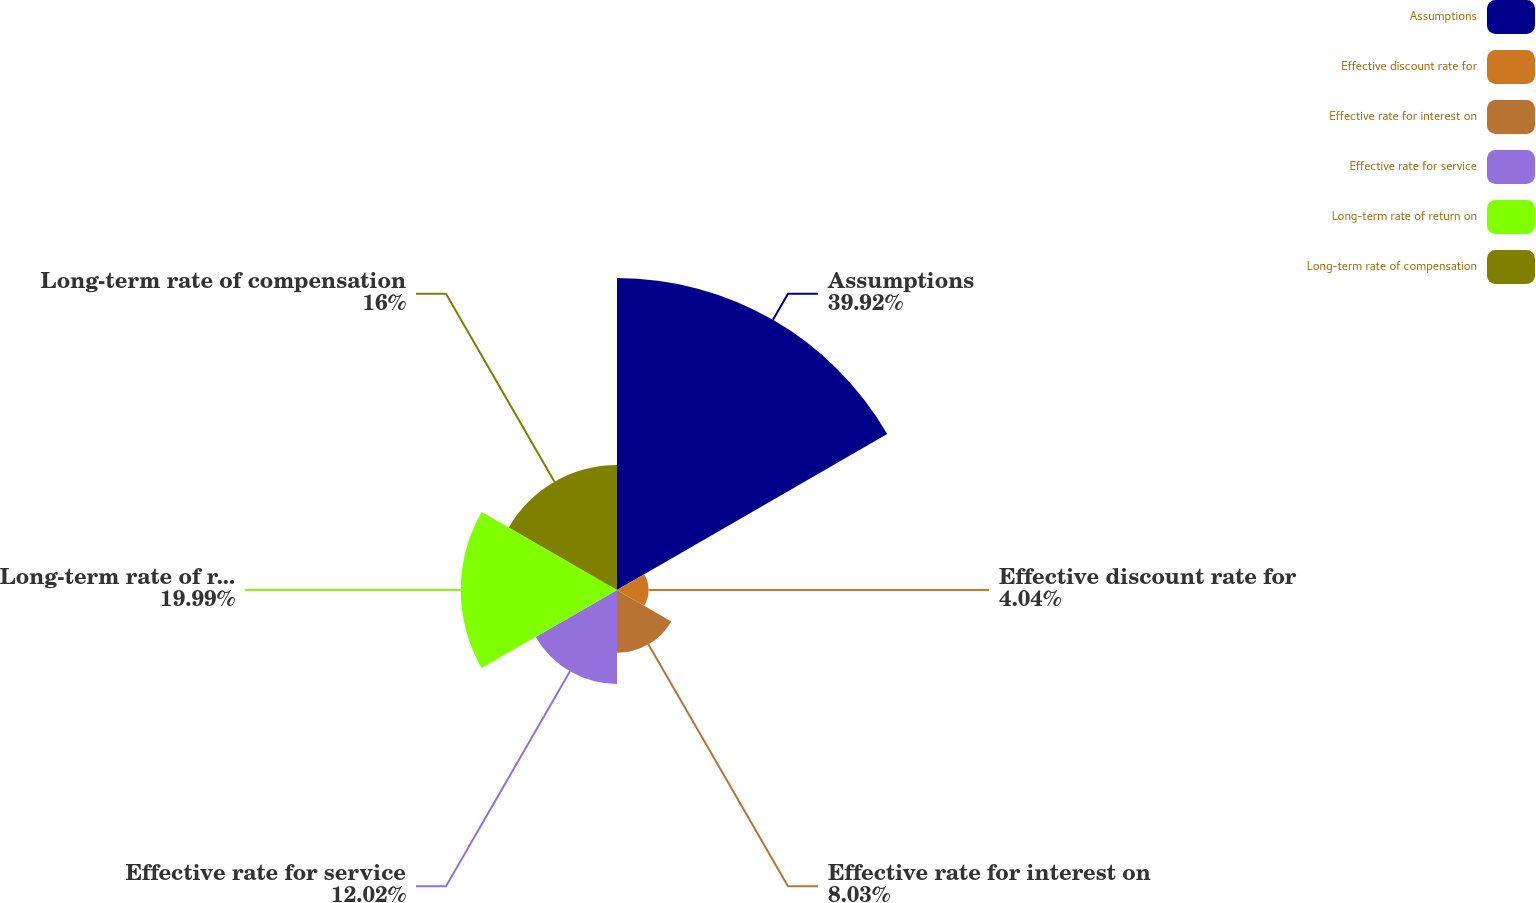<chart> <loc_0><loc_0><loc_500><loc_500><pie_chart><fcel>Assumptions<fcel>Effective discount rate for<fcel>Effective rate for interest on<fcel>Effective rate for service<fcel>Long-term rate of return on<fcel>Long-term rate of compensation<nl><fcel>39.92%<fcel>4.04%<fcel>8.03%<fcel>12.02%<fcel>19.99%<fcel>16.0%<nl></chart> 